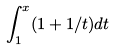Convert formula to latex. <formula><loc_0><loc_0><loc_500><loc_500>\int _ { 1 } ^ { x } ( 1 + 1 / t ) d t</formula> 